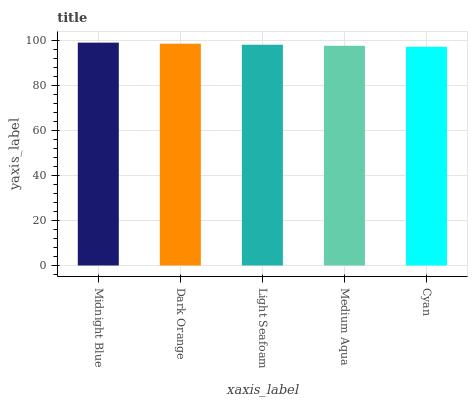Is Cyan the minimum?
Answer yes or no. Yes. Is Midnight Blue the maximum?
Answer yes or no. Yes. Is Dark Orange the minimum?
Answer yes or no. No. Is Dark Orange the maximum?
Answer yes or no. No. Is Midnight Blue greater than Dark Orange?
Answer yes or no. Yes. Is Dark Orange less than Midnight Blue?
Answer yes or no. Yes. Is Dark Orange greater than Midnight Blue?
Answer yes or no. No. Is Midnight Blue less than Dark Orange?
Answer yes or no. No. Is Light Seafoam the high median?
Answer yes or no. Yes. Is Light Seafoam the low median?
Answer yes or no. Yes. Is Dark Orange the high median?
Answer yes or no. No. Is Medium Aqua the low median?
Answer yes or no. No. 